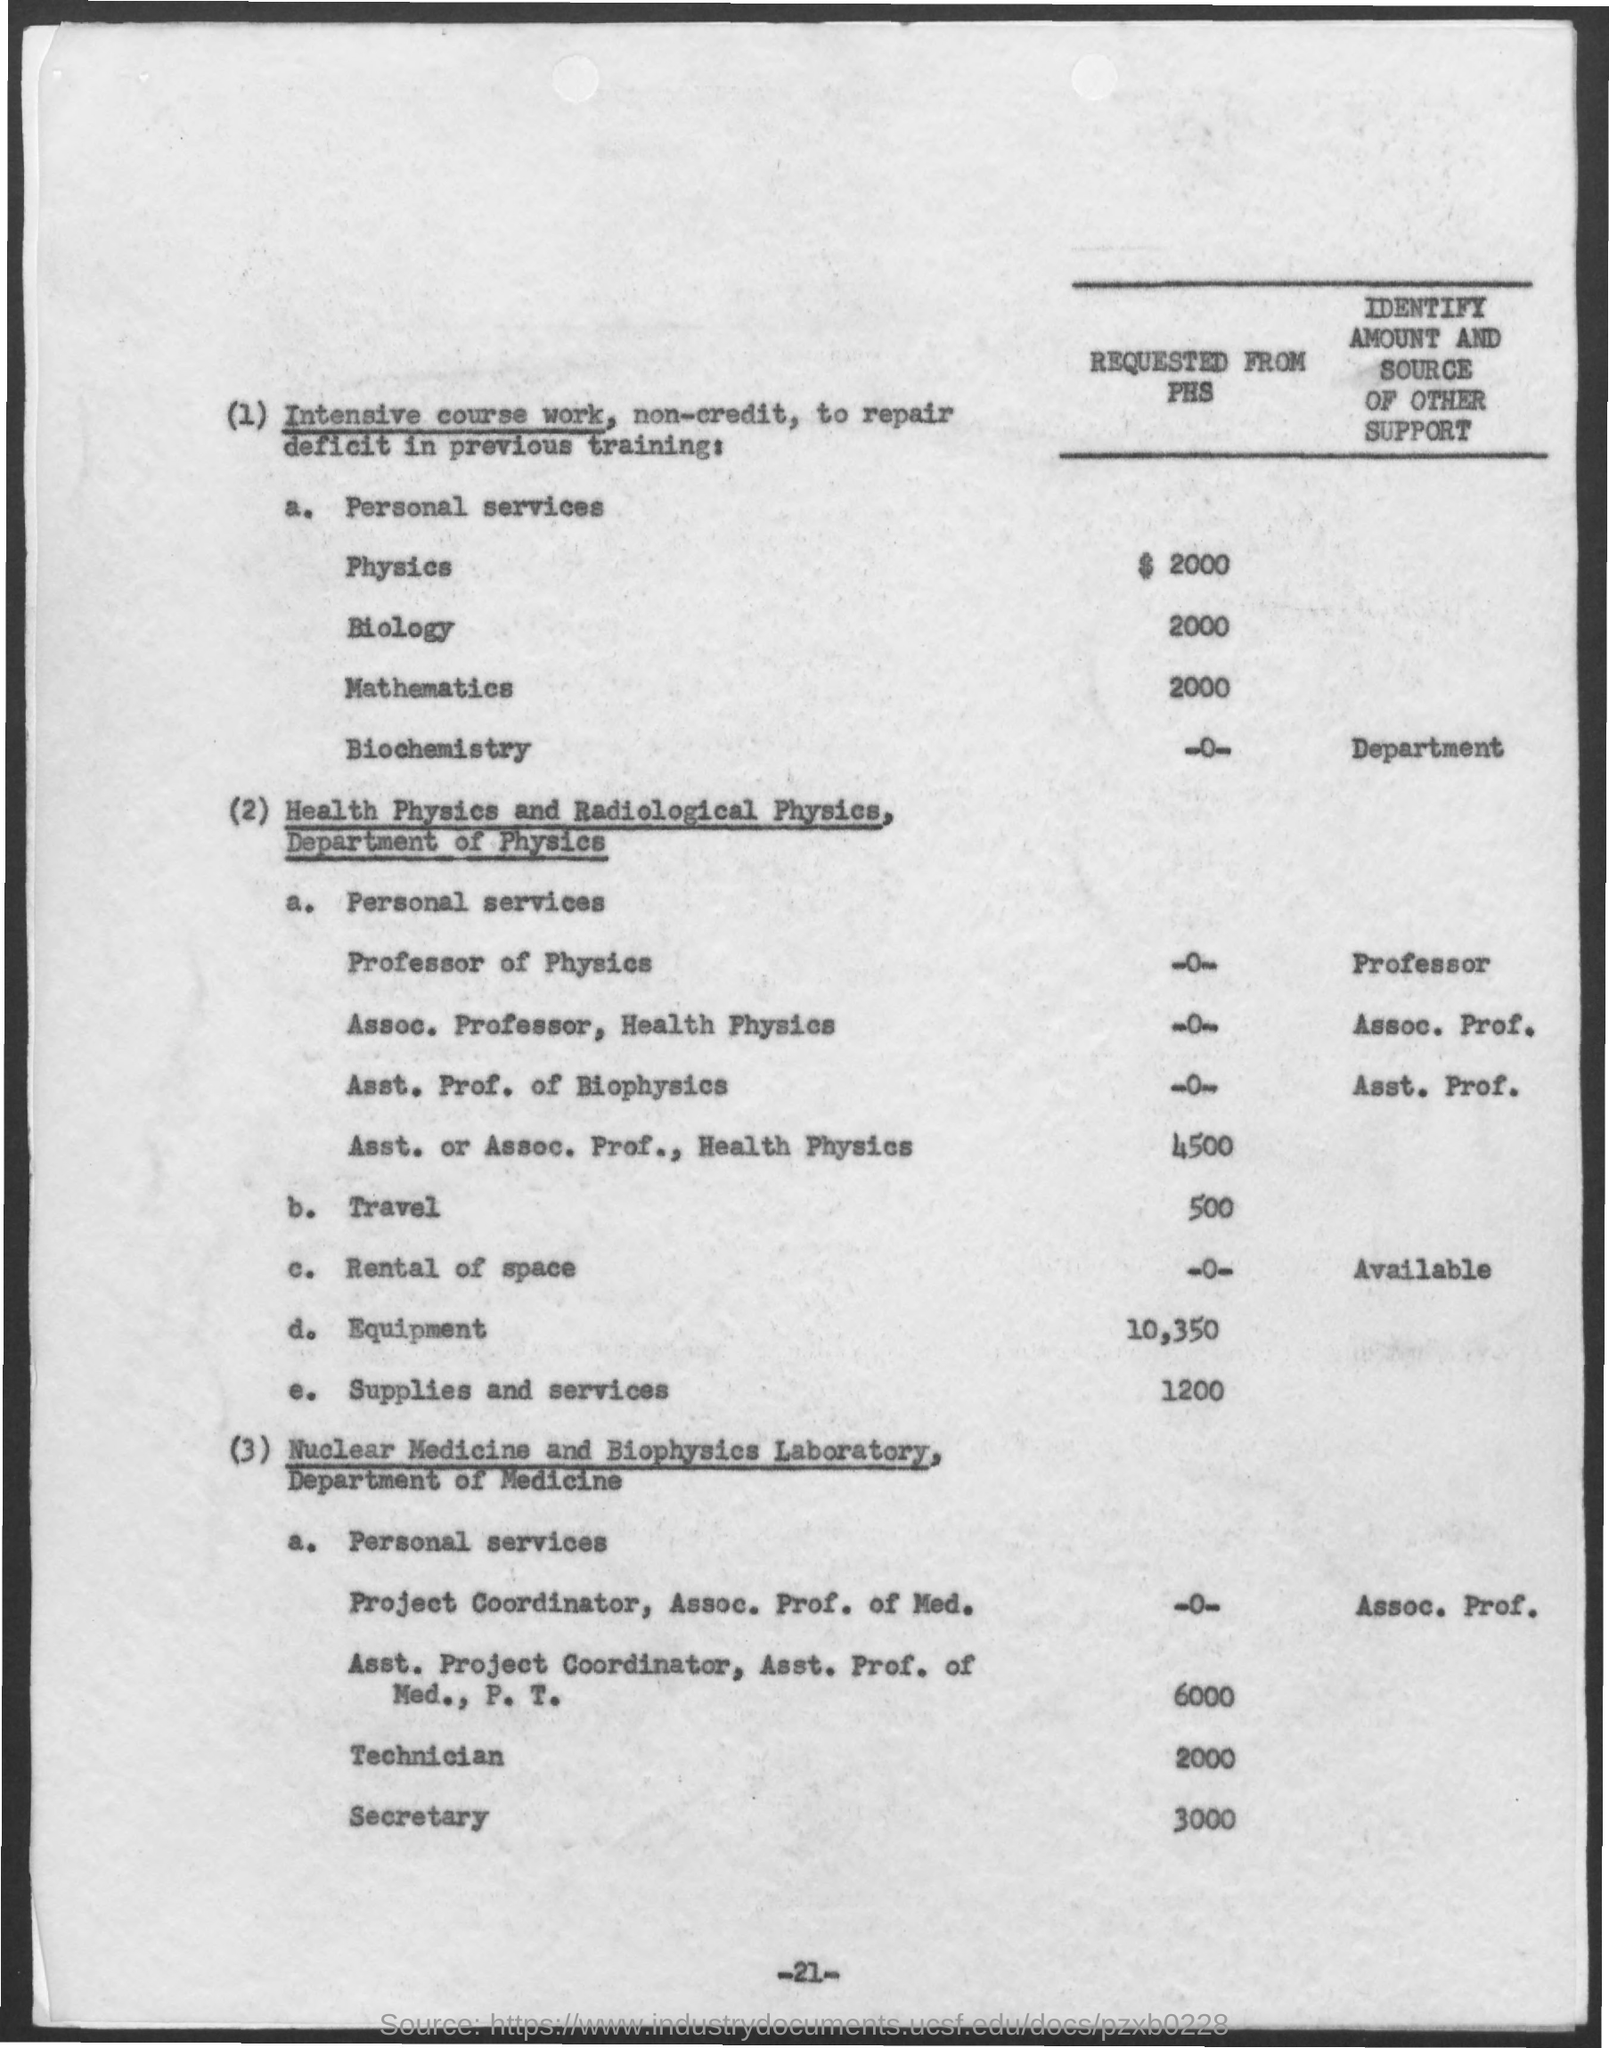What is the Amount Requested from PHS for Physics?
Provide a succinct answer. $ 2000. What is the Amount Requested from PHS for Biology?
Give a very brief answer. 2000. What is the Amount Requested from PHS for Travel?
Keep it short and to the point. 500. What is the Amount Requested from PHS for Equipment?
Keep it short and to the point. 10,350. What is the Amount Requested from PHS for Supplies and Services?
Provide a short and direct response. 1200. What is the Amount Requested from PHS for Mathematics?
Provide a short and direct response. 2000. What is the Amount Requested from PHS for Technician?
Offer a terse response. 2000. What is the Amount Requested from PHS for Secretary?
Your response must be concise. 3000. What is the Page Number?
Offer a very short reply. -21-. 